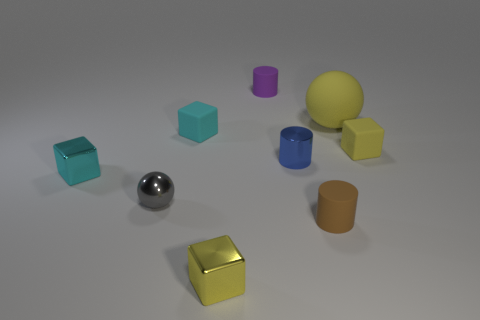There is a rubber cube to the right of the shiny thing right of the tiny rubber thing behind the yellow ball; what is its size?
Give a very brief answer. Small. There is a tiny yellow thing that is in front of the tiny metallic cylinder; is there a small blue metallic object on the right side of it?
Make the answer very short. Yes. Does the blue thing have the same shape as the cyan thing behind the small shiny cylinder?
Provide a succinct answer. No. The ball behind the small metallic sphere is what color?
Your response must be concise. Yellow. There is a metal cube on the right side of the sphere to the left of the purple object; what size is it?
Your answer should be compact. Small. There is a small purple thing that is behind the small blue cylinder; is it the same shape as the small gray shiny thing?
Offer a terse response. No. There is another cyan object that is the same shape as the small cyan rubber object; what material is it?
Ensure brevity in your answer.  Metal. How many things are either rubber blocks on the right side of the rubber ball or small yellow rubber cubes behind the tiny blue cylinder?
Your response must be concise. 1. There is a large matte ball; is it the same color as the small matte cube to the right of the yellow matte ball?
Ensure brevity in your answer.  Yes. What shape is the small cyan thing that is made of the same material as the tiny sphere?
Provide a succinct answer. Cube. 